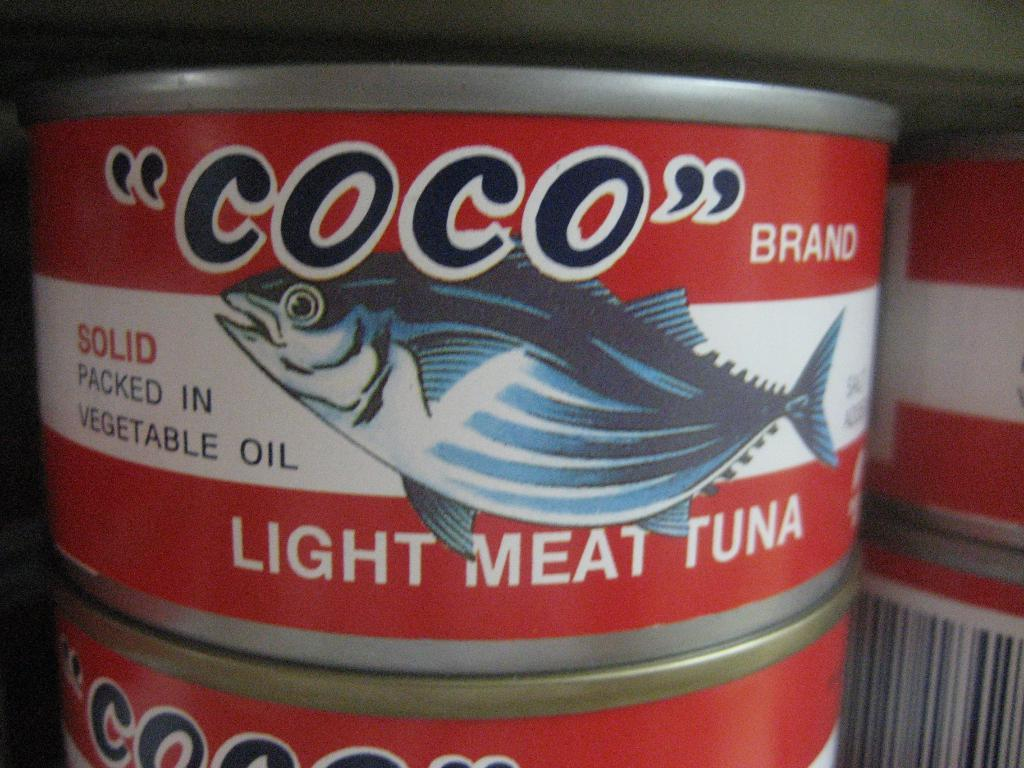Provide a one-sentence caption for the provided image. A can of Coco tuna packed in vegetable oil. 